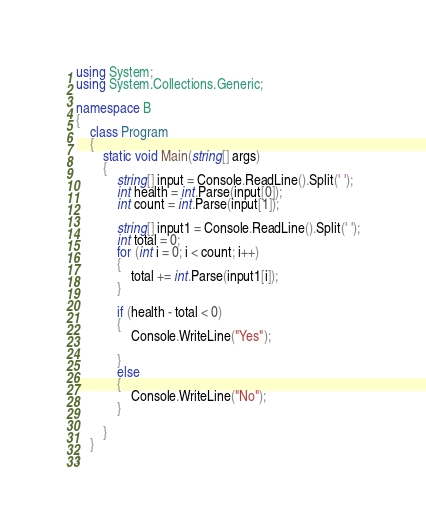Convert code to text. <code><loc_0><loc_0><loc_500><loc_500><_C#_>using System;
using System.Collections.Generic;

namespace B
{
    class Program
    {
        static void Main(string[] args)
        {
            string[] input = Console.ReadLine().Split(' ');
            int health = int.Parse(input[0]);
            int count = int.Parse(input[1]);

            string[] input1 = Console.ReadLine().Split(' ');
            int total = 0;
            for (int i = 0; i < count; i++)
            {
                total += int.Parse(input1[i]);
            }

            if (health - total < 0)
            {
                Console.WriteLine("Yes");

            }
            else
            {
                Console.WriteLine("No");
            }

        }
    }
}
</code> 